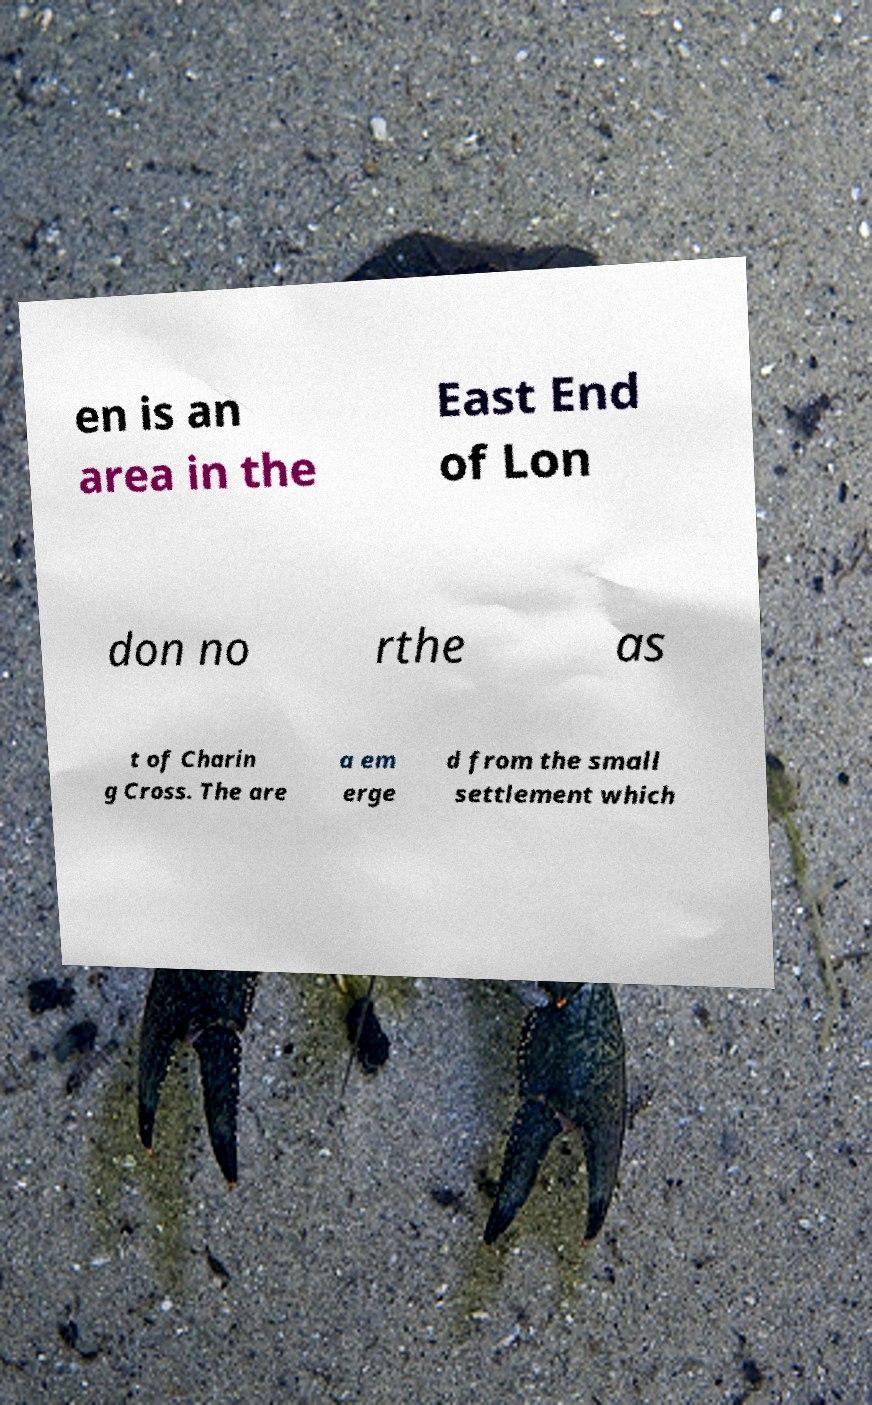Please identify and transcribe the text found in this image. en is an area in the East End of Lon don no rthe as t of Charin g Cross. The are a em erge d from the small settlement which 